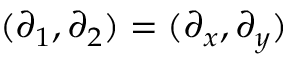Convert formula to latex. <formula><loc_0><loc_0><loc_500><loc_500>( \partial _ { 1 } , \partial _ { 2 } ) = ( \partial _ { x } , \partial _ { y } )</formula> 